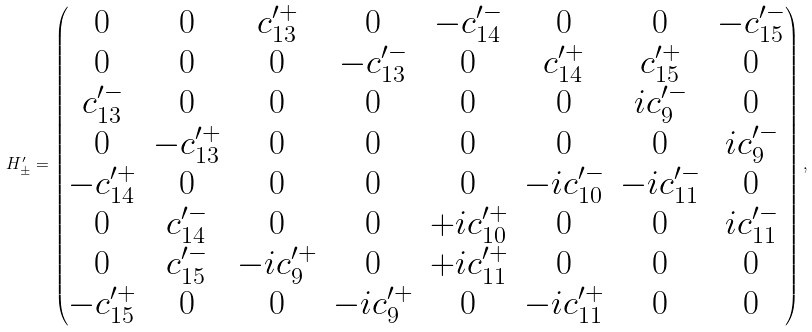<formula> <loc_0><loc_0><loc_500><loc_500>H ^ { \prime } _ { \pm } = \begin{pmatrix} 0 & 0 & { c ^ { \prime + } _ { 1 3 } } & 0 & - { c ^ { \prime - } _ { 1 4 } } & 0 & 0 & - { c ^ { \prime - } _ { 1 5 } } \\ 0 & 0 & 0 & - { c ^ { \prime - } _ { 1 3 } } & 0 & { c ^ { \prime + } _ { 1 4 } } & { c ^ { \prime + } _ { 1 5 } } & 0 \\ { c ^ { \prime - } _ { 1 3 } } & 0 & 0 & 0 & 0 & 0 & i { c ^ { \prime - } _ { 9 } } & 0 \\ 0 & - { c ^ { \prime + } _ { 1 3 } } & 0 & 0 & 0 & 0 & 0 & i { c ^ { \prime - } _ { 9 } } \\ - { c ^ { \prime + } _ { 1 4 } } & 0 & 0 & 0 & 0 & - i c _ { 1 0 } ^ { \prime - } & - i { c ^ { \prime - } _ { 1 1 } } & 0 \\ 0 & { c ^ { \prime - } _ { 1 4 } } & 0 & 0 & + i c _ { 1 0 } ^ { \prime + } & 0 & 0 & i { c ^ { \prime - } _ { 1 1 } } \\ 0 & { c ^ { \prime - } _ { 1 5 } } & - i { c ^ { \prime + } _ { 9 } } & 0 & + i { c ^ { \prime + } _ { 1 1 } } & 0 & 0 & 0 \\ - { c ^ { \prime + } _ { 1 5 } } & 0 & 0 & - i { c ^ { \prime + } _ { 9 } } & 0 & - i { c ^ { \prime + } _ { 1 1 } } & 0 & 0 \end{pmatrix} ,</formula> 